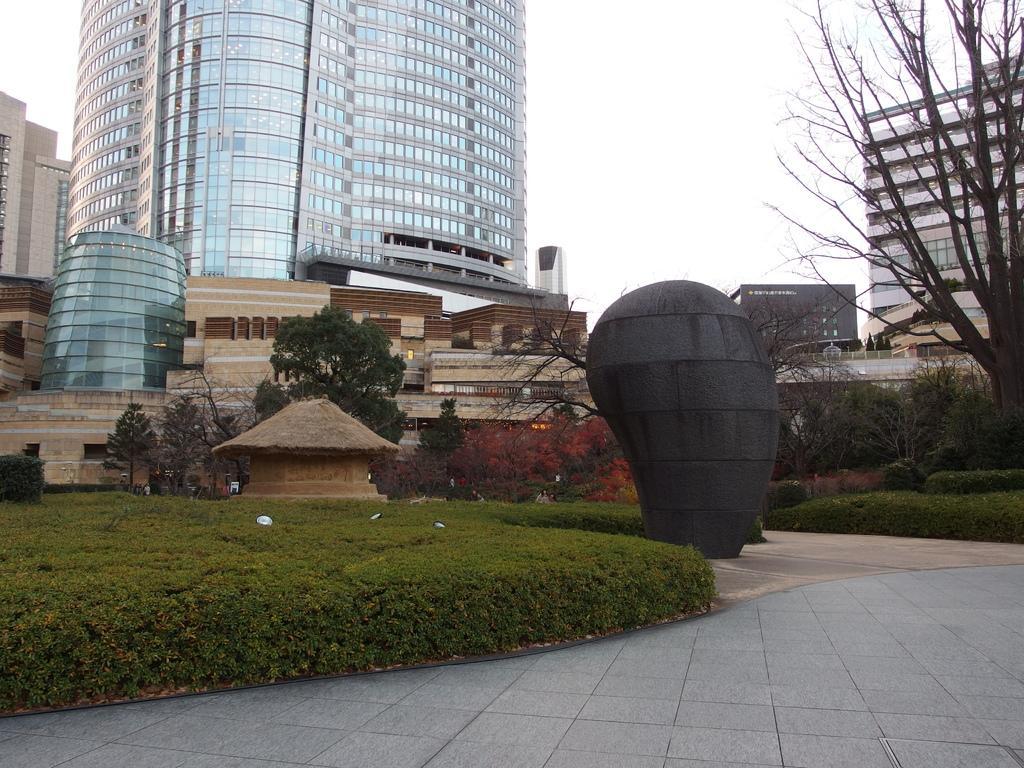In one or two sentences, can you explain what this image depicts? In this picture I can see the skyscraper and buildings. In the centre I can see some trees, plants, grass, hut and other objects. In the top right I can see the sky and clouds. 